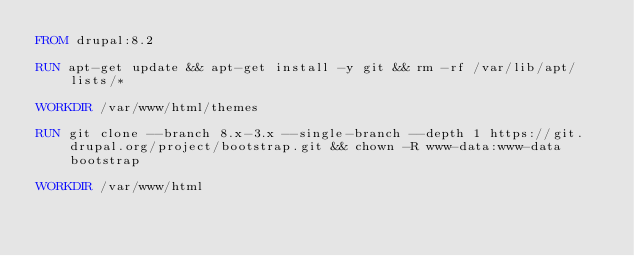<code> <loc_0><loc_0><loc_500><loc_500><_Dockerfile_>FROM drupal:8.2

RUN apt-get update && apt-get install -y git && rm -rf /var/lib/apt/lists/*

WORKDIR /var/www/html/themes

RUN git clone --branch 8.x-3.x --single-branch --depth 1 https://git.drupal.org/project/bootstrap.git && chown -R www-data:www-data bootstrap

WORKDIR /var/www/html
</code> 